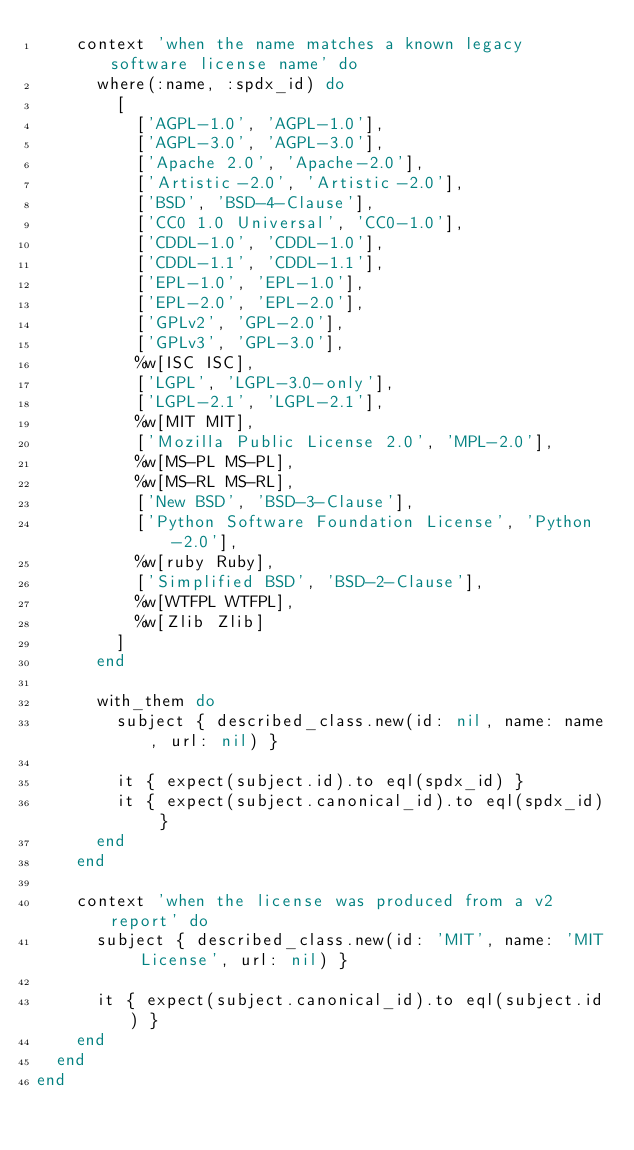<code> <loc_0><loc_0><loc_500><loc_500><_Ruby_>    context 'when the name matches a known legacy software license name' do
      where(:name, :spdx_id) do
        [
          ['AGPL-1.0', 'AGPL-1.0'],
          ['AGPL-3.0', 'AGPL-3.0'],
          ['Apache 2.0', 'Apache-2.0'],
          ['Artistic-2.0', 'Artistic-2.0'],
          ['BSD', 'BSD-4-Clause'],
          ['CC0 1.0 Universal', 'CC0-1.0'],
          ['CDDL-1.0', 'CDDL-1.0'],
          ['CDDL-1.1', 'CDDL-1.1'],
          ['EPL-1.0', 'EPL-1.0'],
          ['EPL-2.0', 'EPL-2.0'],
          ['GPLv2', 'GPL-2.0'],
          ['GPLv3', 'GPL-3.0'],
          %w[ISC ISC],
          ['LGPL', 'LGPL-3.0-only'],
          ['LGPL-2.1', 'LGPL-2.1'],
          %w[MIT MIT],
          ['Mozilla Public License 2.0', 'MPL-2.0'],
          %w[MS-PL MS-PL],
          %w[MS-RL MS-RL],
          ['New BSD', 'BSD-3-Clause'],
          ['Python Software Foundation License', 'Python-2.0'],
          %w[ruby Ruby],
          ['Simplified BSD', 'BSD-2-Clause'],
          %w[WTFPL WTFPL],
          %w[Zlib Zlib]
        ]
      end

      with_them do
        subject { described_class.new(id: nil, name: name, url: nil) }

        it { expect(subject.id).to eql(spdx_id) }
        it { expect(subject.canonical_id).to eql(spdx_id) }
      end
    end

    context 'when the license was produced from a v2 report' do
      subject { described_class.new(id: 'MIT', name: 'MIT License', url: nil) }

      it { expect(subject.canonical_id).to eql(subject.id) }
    end
  end
end
</code> 